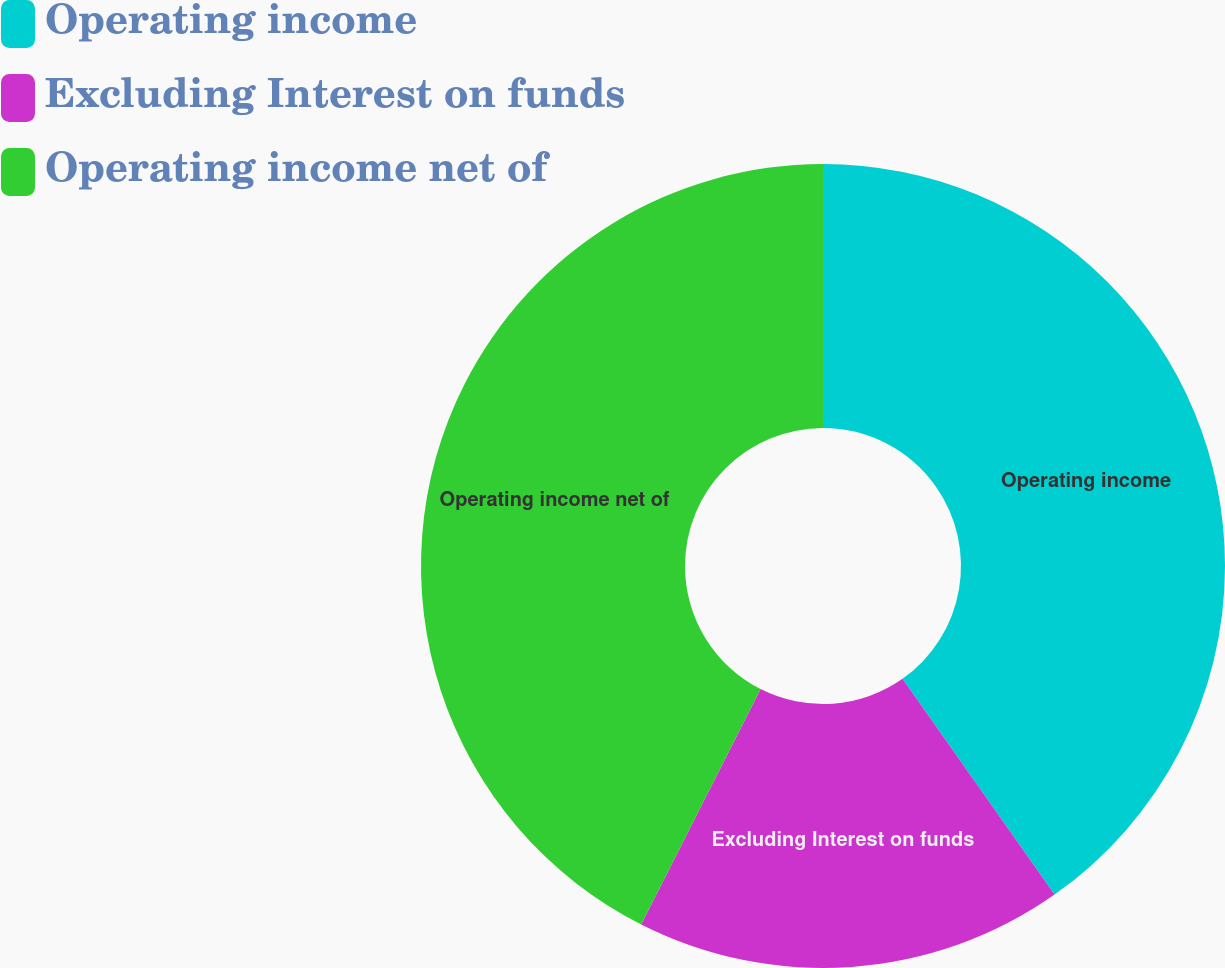Convert chart to OTSL. <chart><loc_0><loc_0><loc_500><loc_500><pie_chart><fcel>Operating income<fcel>Excluding Interest on funds<fcel>Operating income net of<nl><fcel>40.23%<fcel>17.24%<fcel>42.53%<nl></chart> 